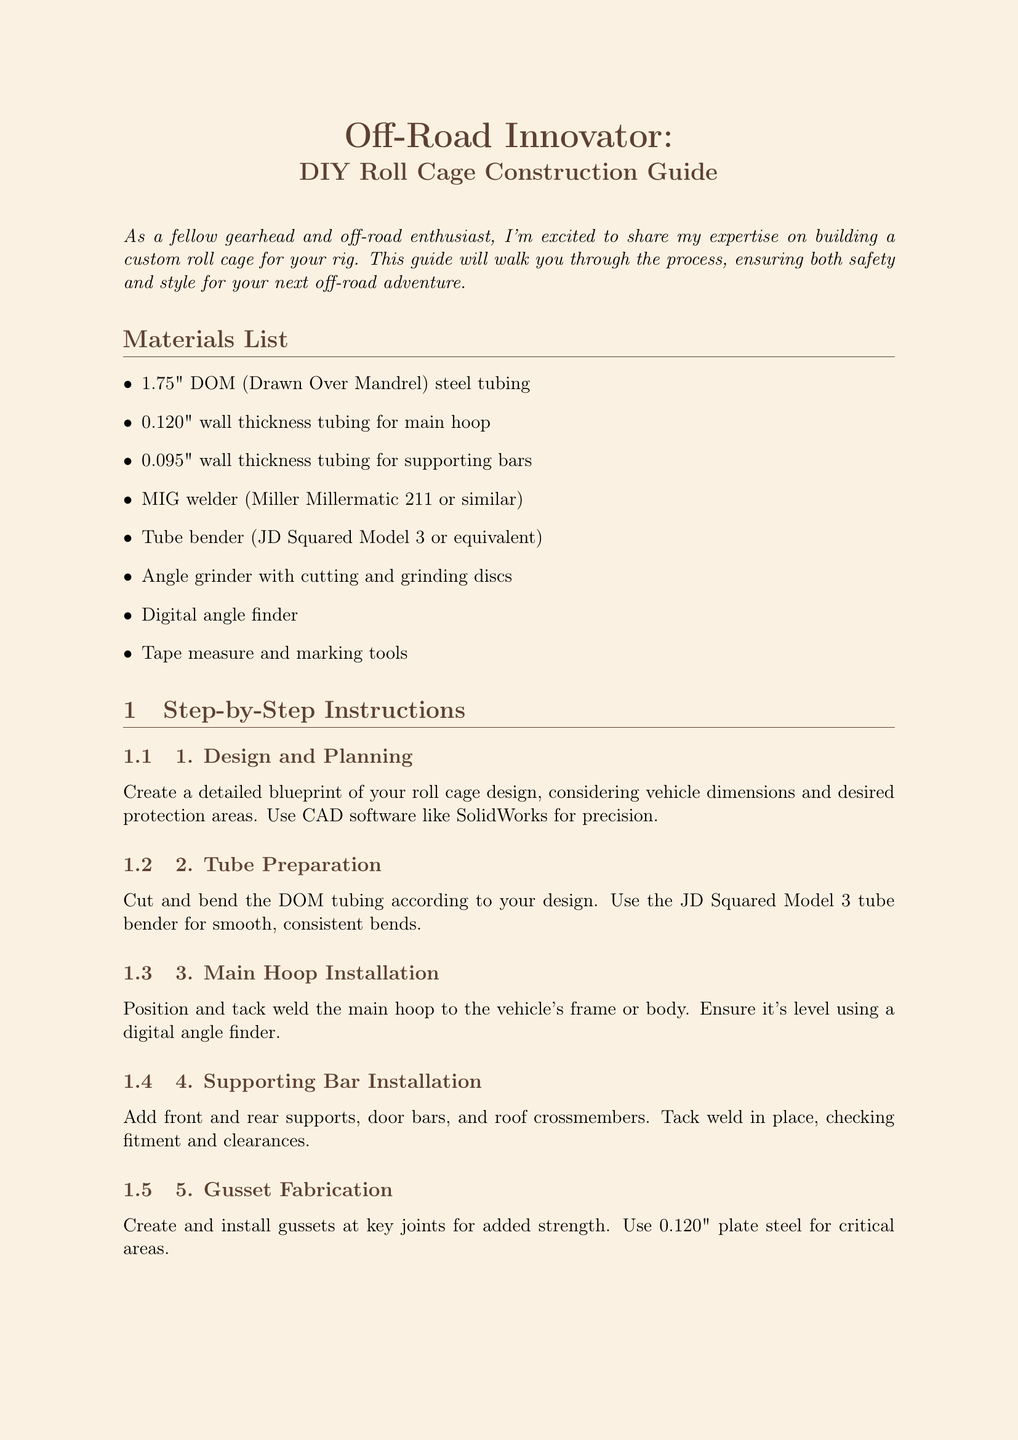what is the title of the newsletter? The title of the newsletter can be found at the beginning of the document and is "Off-Road Innovator: DIY Roll Cage Construction Guide."
Answer: Off-Road Innovator: DIY Roll Cage Construction Guide how thick is the wall of the main hoop tubing? The wall thickness for the main hoop tubing is specified in the materials list as 0.120 inches.
Answer: 0.120 inches how many steps are in the step-by-step instructions? The document lists a total of six steps in the step-by-step instructions section.
Answer: 6 what material is recommended for tubing? The newsletter recommends 4130 chromoly steel for its strength-to-weight ratio.
Answer: 4130 chromoly steel which welding machine is mentioned in the materials list? The welding machine specified in the materials list is the Miller Millermatic 211.
Answer: Miller Millermatic 211 what is one common mistake to avoid during roll cage construction? The document lists several mistakes, one being underestimating the importance of proper fitment before final welding.
Answer: Underestimating proper fitment how many safety certification tips are provided? The safety certification tips section contains four different tips, enumerated in the document.
Answer: 4 what is the expert advice given regarding accessory integration? The expert advice discusses the benefits of integrating mounting points for accessories without compromising safety.
Answer: Integrating mounting points for accessories 